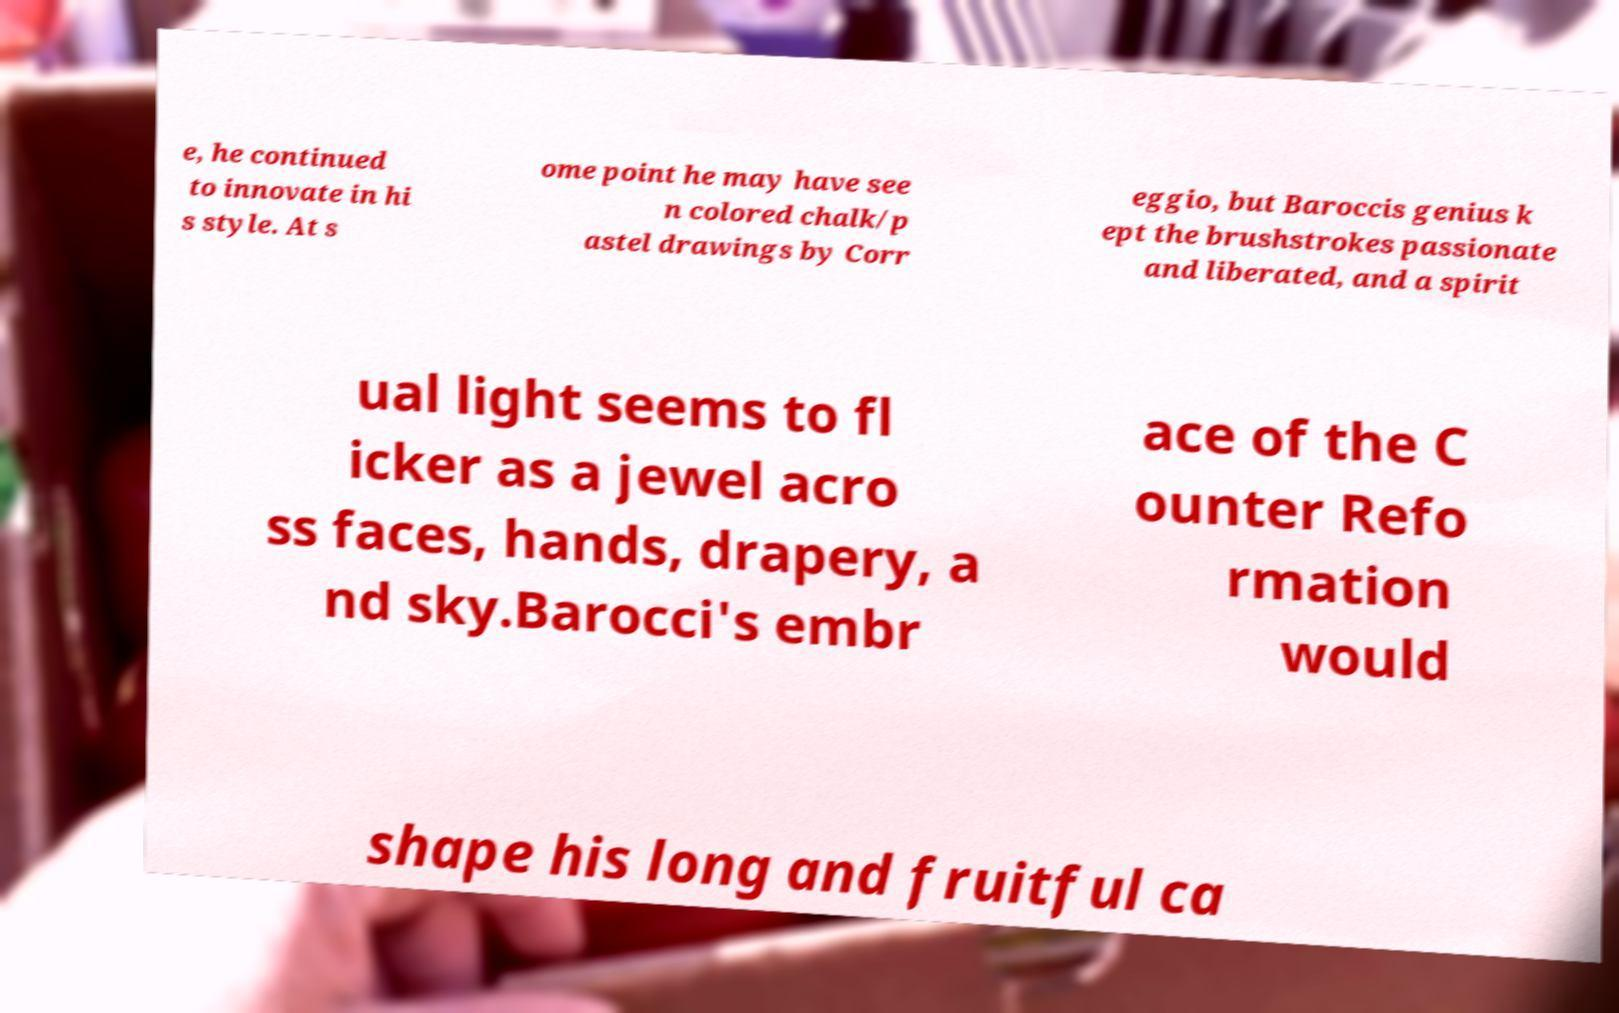Can you read and provide the text displayed in the image?This photo seems to have some interesting text. Can you extract and type it out for me? e, he continued to innovate in hi s style. At s ome point he may have see n colored chalk/p astel drawings by Corr eggio, but Baroccis genius k ept the brushstrokes passionate and liberated, and a spirit ual light seems to fl icker as a jewel acro ss faces, hands, drapery, a nd sky.Barocci's embr ace of the C ounter Refo rmation would shape his long and fruitful ca 